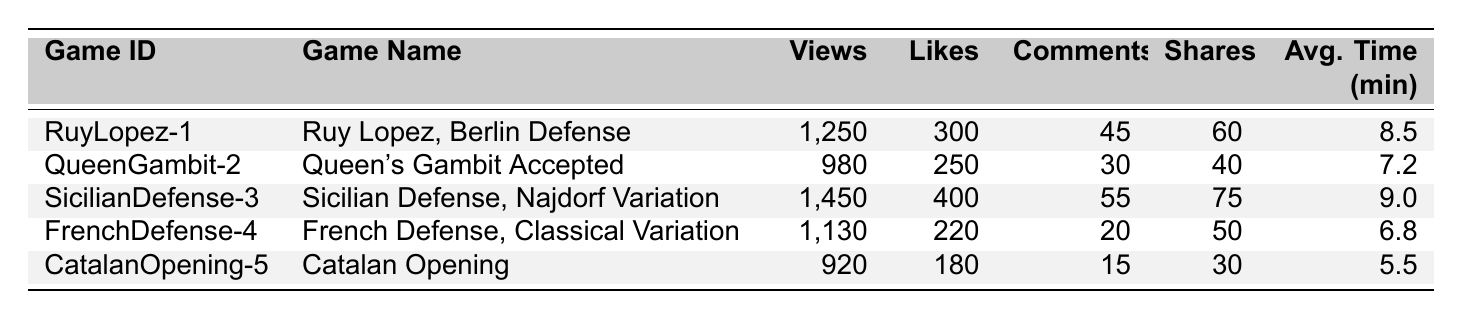What is the game with the highest number of views? The game "Sicilian Defense, Najdorf Variation" has 1,450 views, which is higher than any other game listed in the table.
Answer: Sicilian Defense, Najdorf Variation How many likes did the "French Defense, Classical Variation" receive? The table indicates that the "French Defense, Classical Variation" received 220 likes.
Answer: 220 Which game has the least average time spent by users? By comparing the average time spent on each game, "Catalan Opening" has the lowest average time of 5.5 minutes.
Answer: Catalan Opening What is the total number of shares for all games combined? Adding the shares: 60 + 40 + 75 + 50 + 30 = 255. Hence, the total number of shares for all games is 255.
Answer: 255 Did the "Queen's Gambit Accepted" have more comments than the "Catalan Opening"? The "Queen's Gambit Accepted" has 30 comments, while the "Catalan Opening" only has 15 comments. Therefore, it had more comments.
Answer: Yes What is the average number of likes across all games? To find the average, sum the likes (300 + 250 + 400 + 220 + 180 = 1,350) and divide by the number of games (5). The average is 1,350 / 5 = 270.
Answer: 270 Which game had both the highest number of comments and likes? "Sicilian Defense, Najdorf Variation" had the highest likes (400) and comments (55) compared to the other games, making it the game with both metrics at their highest.
Answer: Sicilian Defense, Najdorf Variation How does the average time spent on "Ruy Lopez, Berlin Defense" compare to "Queen's Gambit Accepted"? "Ruy Lopez, Berlin Defense" has an average of 8.5 minutes, while "Queen's Gambit Accepted" has 7.2 minutes. Therefore, it is longer by 1.3 minutes.
Answer: Longer by 1.3 minutes What is the difference in views between the "Sicilian Defense" and the "Catalan Opening"? The views for "Sicilian Defense" are 1,450 and for "Catalan Opening" are 920. The difference is calculated as 1,450 - 920 = 530.
Answer: 530 Which game had the fewest views and what was that number? The game with the fewest views is "Catalan Opening" with only 920 views.
Answer: Catalan Opening, 920 views 